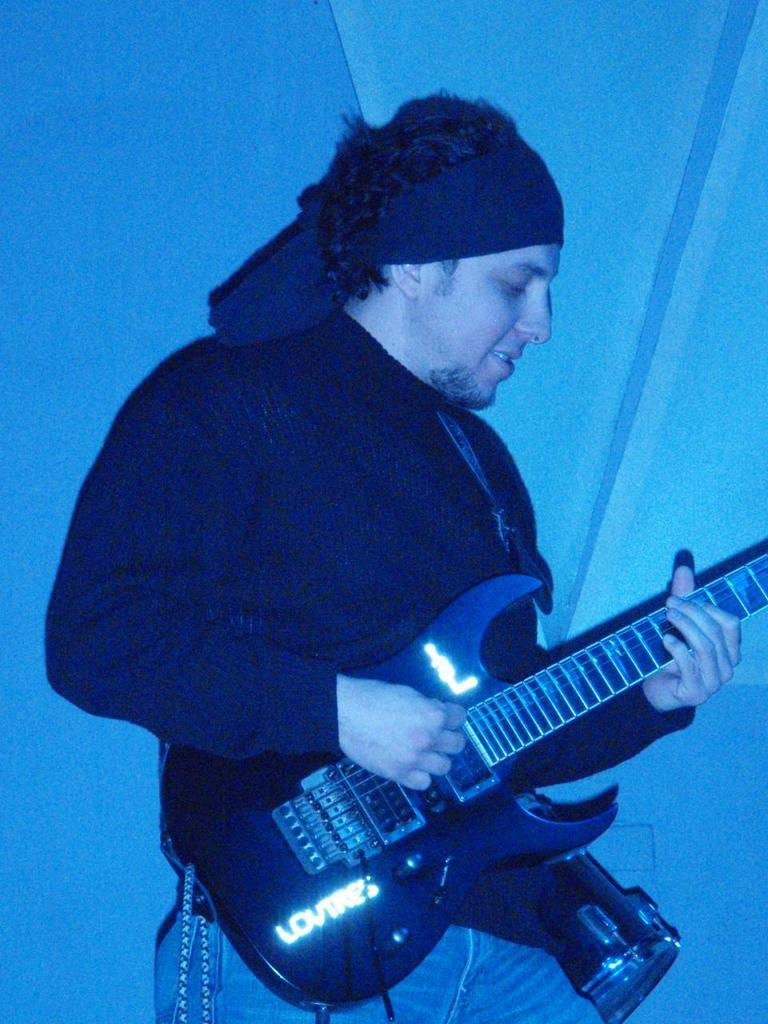What is the main subject of the image? There is a person in the image. What is the person wearing? The person is wearing a black color shirt. What activity is the person engaged in? The person is playing a guitar. What type of cork can be seen in the person's hand in the image? There is no cork present in the image; the person is playing a guitar. Is the person wearing a hat in the image? The provided facts do not mention a hat, so we cannot determine if the person is wearing one. 